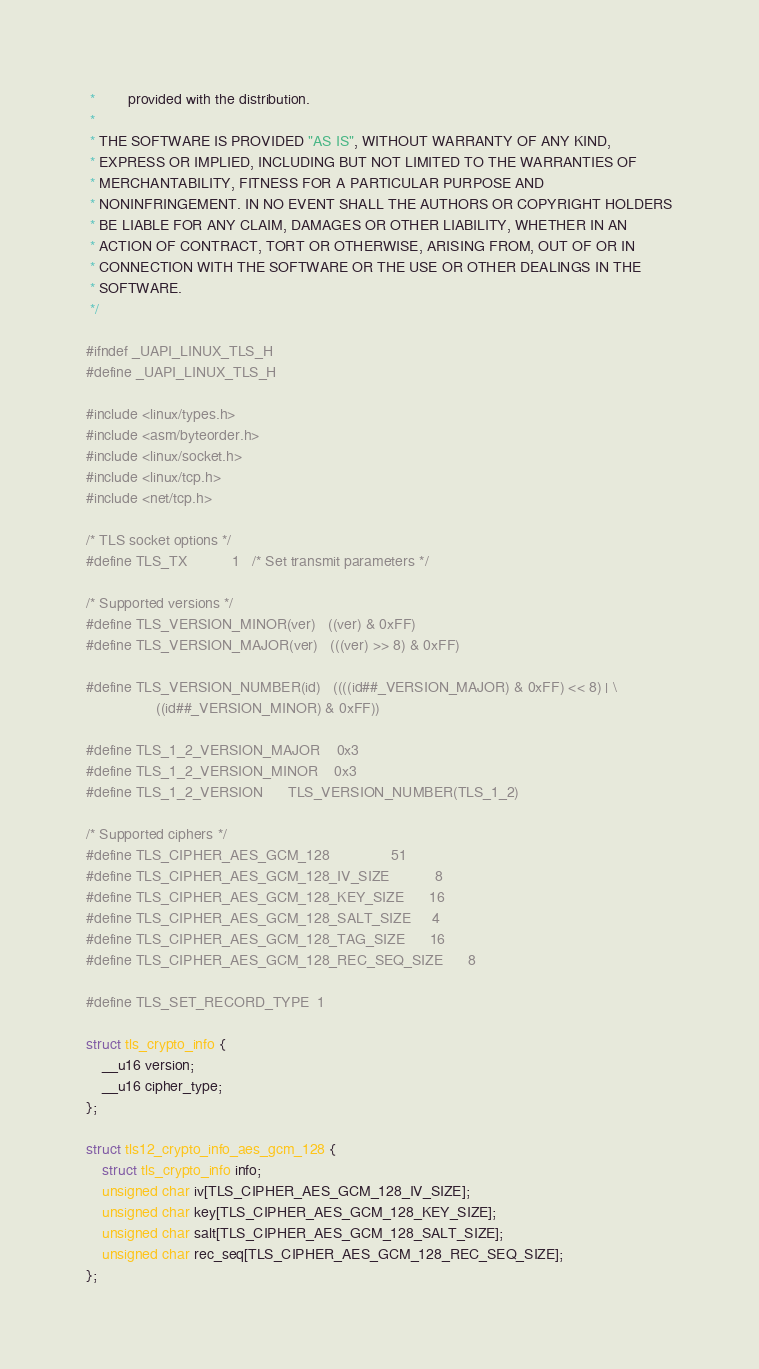Convert code to text. <code><loc_0><loc_0><loc_500><loc_500><_C_> *        provided with the distribution.
 *
 * THE SOFTWARE IS PROVIDED "AS IS", WITHOUT WARRANTY OF ANY KIND,
 * EXPRESS OR IMPLIED, INCLUDING BUT NOT LIMITED TO THE WARRANTIES OF
 * MERCHANTABILITY, FITNESS FOR A PARTICULAR PURPOSE AND
 * NONINFRINGEMENT. IN NO EVENT SHALL THE AUTHORS OR COPYRIGHT HOLDERS
 * BE LIABLE FOR ANY CLAIM, DAMAGES OR OTHER LIABILITY, WHETHER IN AN
 * ACTION OF CONTRACT, TORT OR OTHERWISE, ARISING FROM, OUT OF OR IN
 * CONNECTION WITH THE SOFTWARE OR THE USE OR OTHER DEALINGS IN THE
 * SOFTWARE.
 */

#ifndef _UAPI_LINUX_TLS_H
#define _UAPI_LINUX_TLS_H

#include <linux/types.h>
#include <asm/byteorder.h>
#include <linux/socket.h>
#include <linux/tcp.h>
#include <net/tcp.h>

/* TLS socket options */
#define TLS_TX			1	/* Set transmit parameters */

/* Supported versions */
#define TLS_VERSION_MINOR(ver)	((ver) & 0xFF)
#define TLS_VERSION_MAJOR(ver)	(((ver) >> 8) & 0xFF)

#define TLS_VERSION_NUMBER(id)	((((id##_VERSION_MAJOR) & 0xFF) << 8) |	\
				 ((id##_VERSION_MINOR) & 0xFF))

#define TLS_1_2_VERSION_MAJOR	0x3
#define TLS_1_2_VERSION_MINOR	0x3
#define TLS_1_2_VERSION		TLS_VERSION_NUMBER(TLS_1_2)

/* Supported ciphers */
#define TLS_CIPHER_AES_GCM_128				51
#define TLS_CIPHER_AES_GCM_128_IV_SIZE			8
#define TLS_CIPHER_AES_GCM_128_KEY_SIZE		16
#define TLS_CIPHER_AES_GCM_128_SALT_SIZE		4
#define TLS_CIPHER_AES_GCM_128_TAG_SIZE		16
#define TLS_CIPHER_AES_GCM_128_REC_SEQ_SIZE		8

#define TLS_SET_RECORD_TYPE	1

struct tls_crypto_info {
	__u16 version;
	__u16 cipher_type;
};

struct tls12_crypto_info_aes_gcm_128 {
	struct tls_crypto_info info;
	unsigned char iv[TLS_CIPHER_AES_GCM_128_IV_SIZE];
	unsigned char key[TLS_CIPHER_AES_GCM_128_KEY_SIZE];
	unsigned char salt[TLS_CIPHER_AES_GCM_128_SALT_SIZE];
	unsigned char rec_seq[TLS_CIPHER_AES_GCM_128_REC_SEQ_SIZE];
};
</code> 